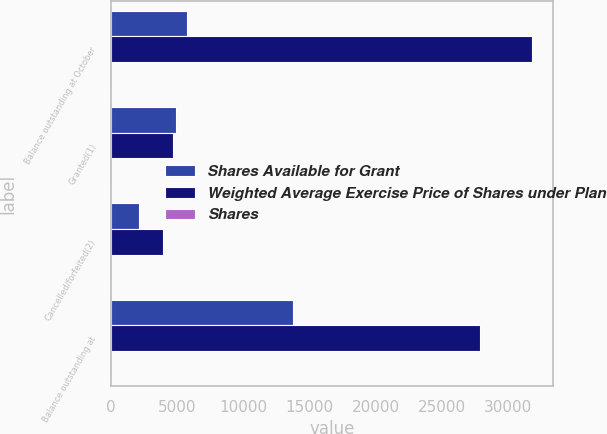Convert chart. <chart><loc_0><loc_0><loc_500><loc_500><stacked_bar_chart><ecel><fcel>Balance outstanding at October<fcel>Granted(1)<fcel>Cancelled/forfeited(2)<fcel>Balance outstanding at<nl><fcel>Shares Available for Grant<fcel>5710<fcel>4908<fcel>2113<fcel>13754<nl><fcel>Weighted Average Exercise Price of Shares under Plan<fcel>31763<fcel>4668<fcel>3918<fcel>27868<nl><fcel>Shares<fcel>13.63<fcel>8.47<fcel>13.66<fcel>11.96<nl></chart> 